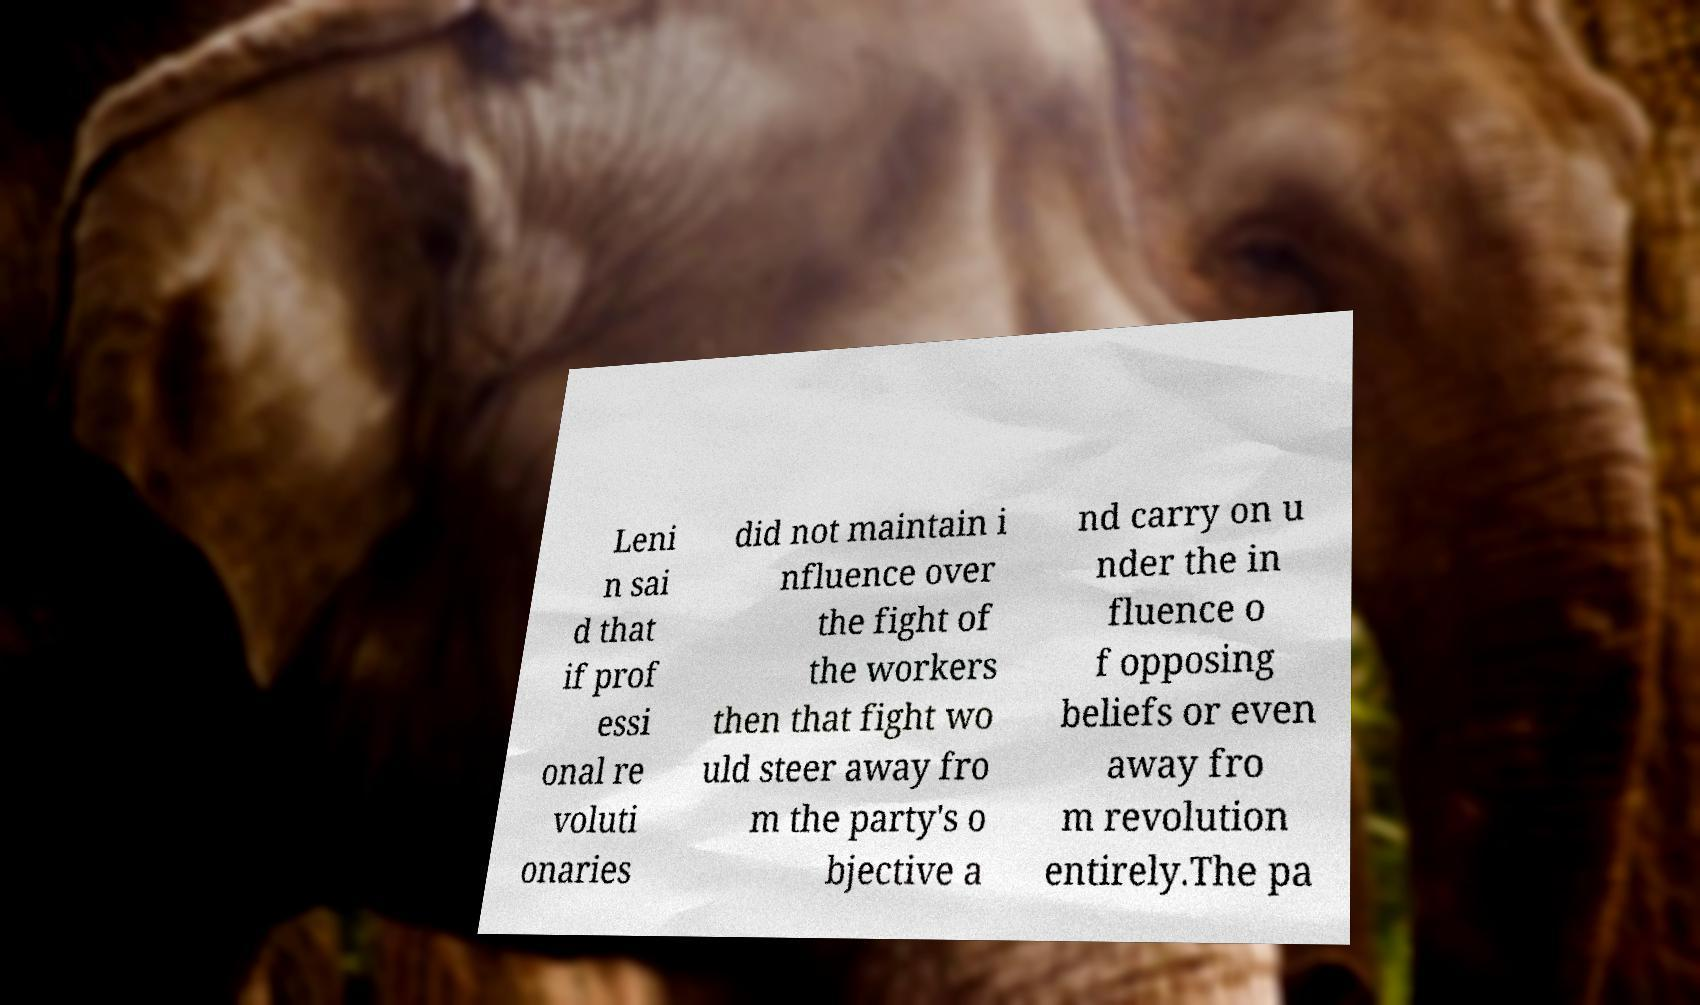I need the written content from this picture converted into text. Can you do that? Leni n sai d that if prof essi onal re voluti onaries did not maintain i nfluence over the fight of the workers then that fight wo uld steer away fro m the party's o bjective a nd carry on u nder the in fluence o f opposing beliefs or even away fro m revolution entirely.The pa 